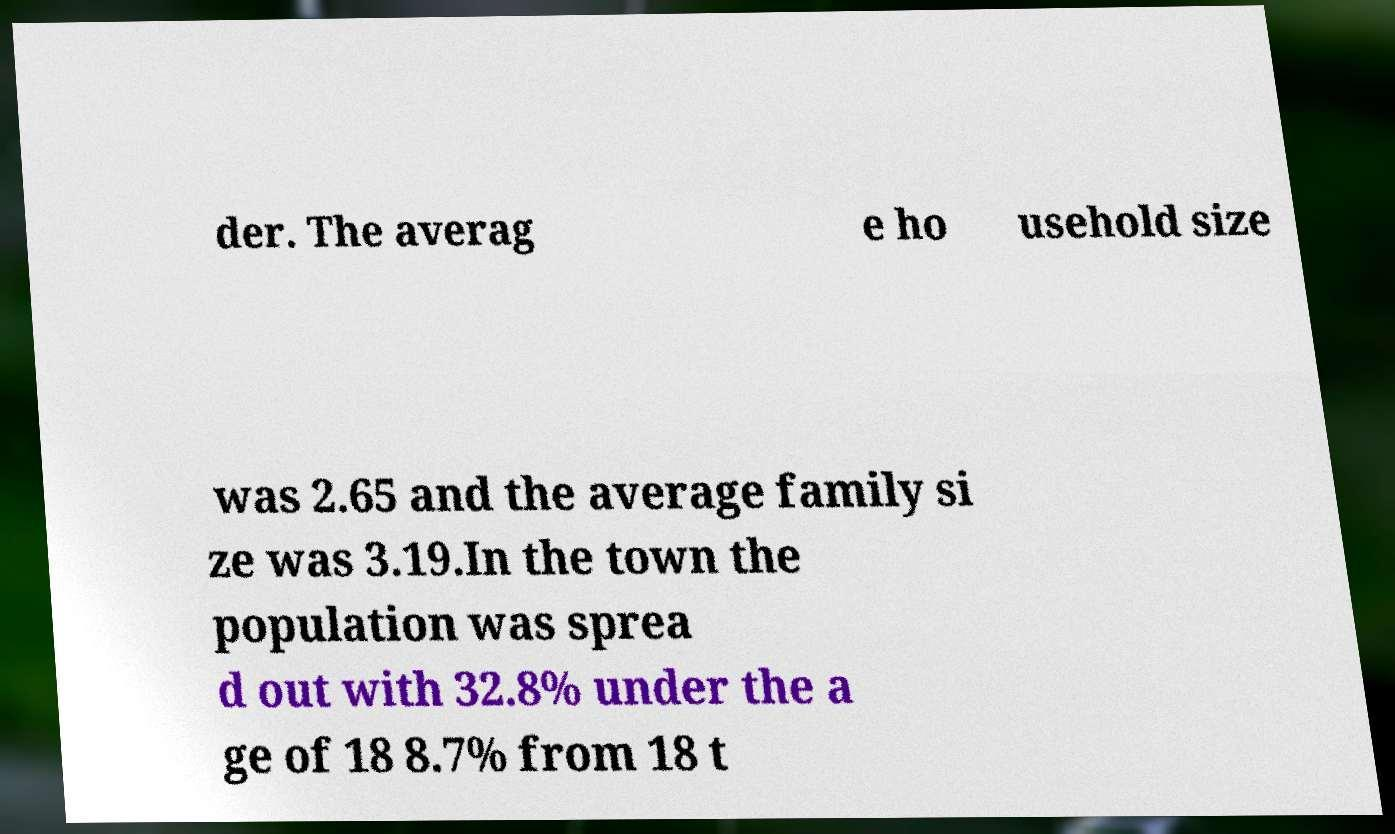Can you accurately transcribe the text from the provided image for me? der. The averag e ho usehold size was 2.65 and the average family si ze was 3.19.In the town the population was sprea d out with 32.8% under the a ge of 18 8.7% from 18 t 